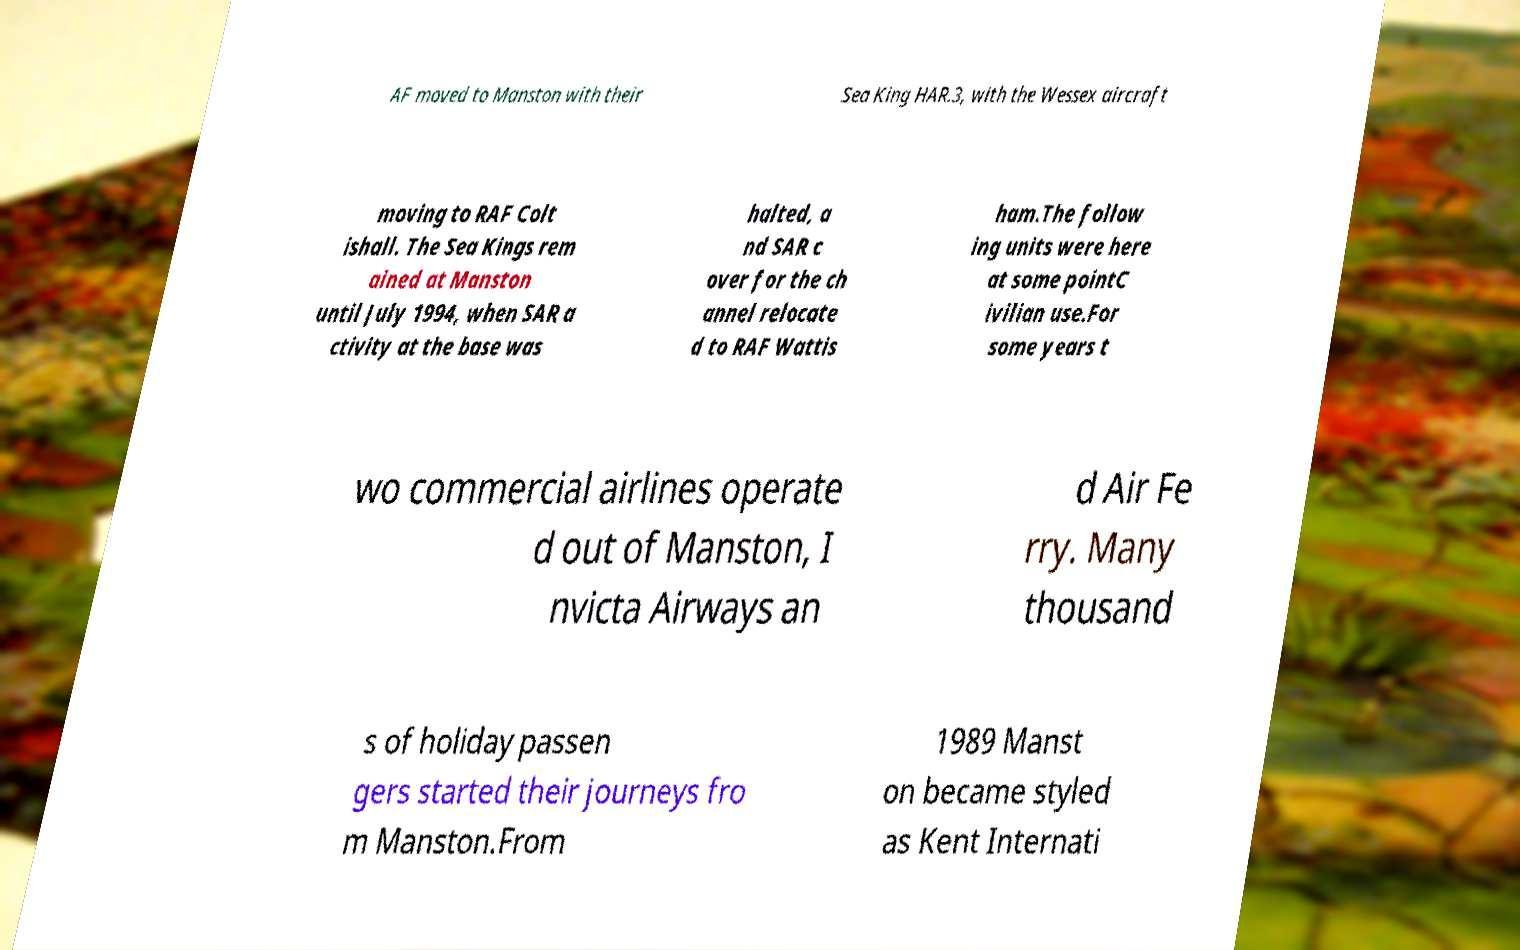Please read and relay the text visible in this image. What does it say? AF moved to Manston with their Sea King HAR.3, with the Wessex aircraft moving to RAF Colt ishall. The Sea Kings rem ained at Manston until July 1994, when SAR a ctivity at the base was halted, a nd SAR c over for the ch annel relocate d to RAF Wattis ham.The follow ing units were here at some pointC ivilian use.For some years t wo commercial airlines operate d out of Manston, I nvicta Airways an d Air Fe rry. Many thousand s of holiday passen gers started their journeys fro m Manston.From 1989 Manst on became styled as Kent Internati 